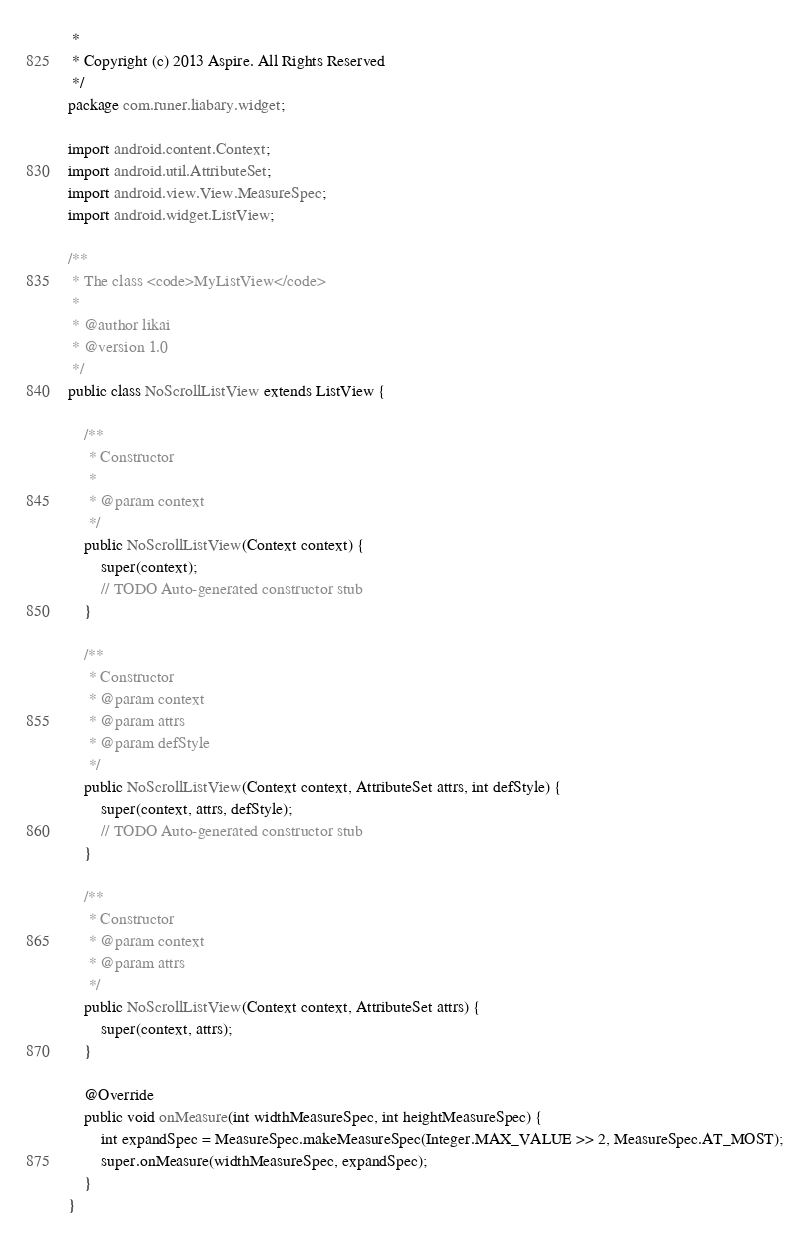<code> <loc_0><loc_0><loc_500><loc_500><_Java_> *
 * Copyright (c) 2013 Aspire. All Rights Reserved
 */
package com.runer.liabary.widget;

import android.content.Context;
import android.util.AttributeSet;
import android.view.View.MeasureSpec;
import android.widget.ListView;

/**
 * The class <code>MyListView</code>
 * 
 * @author likai
 * @version 1.0
 */
public class NoScrollListView extends ListView {

    /**
     * Constructor
     * 
     * @param context
     */
    public NoScrollListView(Context context) {
        super(context);
        // TODO Auto-generated constructor stub
    }

    /**
     * Constructor
     * @param context
     * @param attrs
     * @param defStyle
     */
    public NoScrollListView(Context context, AttributeSet attrs, int defStyle) {
        super(context, attrs, defStyle);
        // TODO Auto-generated constructor stub
    }

    /**
     * Constructor
     * @param context
     * @param attrs
     */
    public NoScrollListView(Context context, AttributeSet attrs) {
        super(context, attrs);
    }

    @Override
    public void onMeasure(int widthMeasureSpec, int heightMeasureSpec) {
        int expandSpec = MeasureSpec.makeMeasureSpec(Integer.MAX_VALUE >> 2, MeasureSpec.AT_MOST);
        super.onMeasure(widthMeasureSpec, expandSpec);
    }
}
</code> 